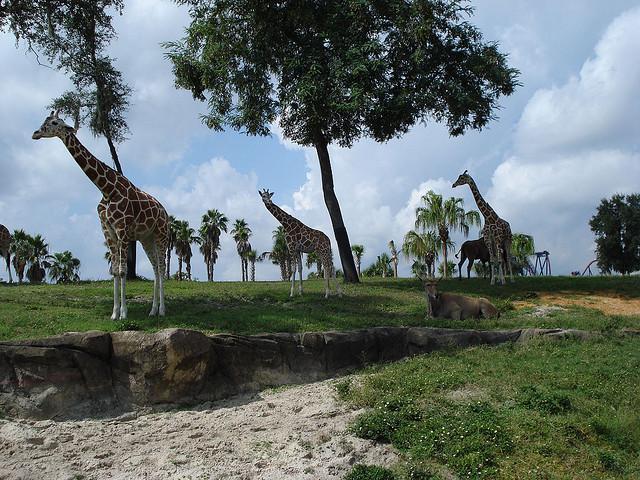How many giraffes are in the picture?
Give a very brief answer. 3. How many giraffe are on the grass?
Give a very brief answer. 3. How many large rocks do you see?
Give a very brief answer. 1. How many giraffes are there?
Give a very brief answer. 3. How many people are wearing black shirt?
Give a very brief answer. 0. 